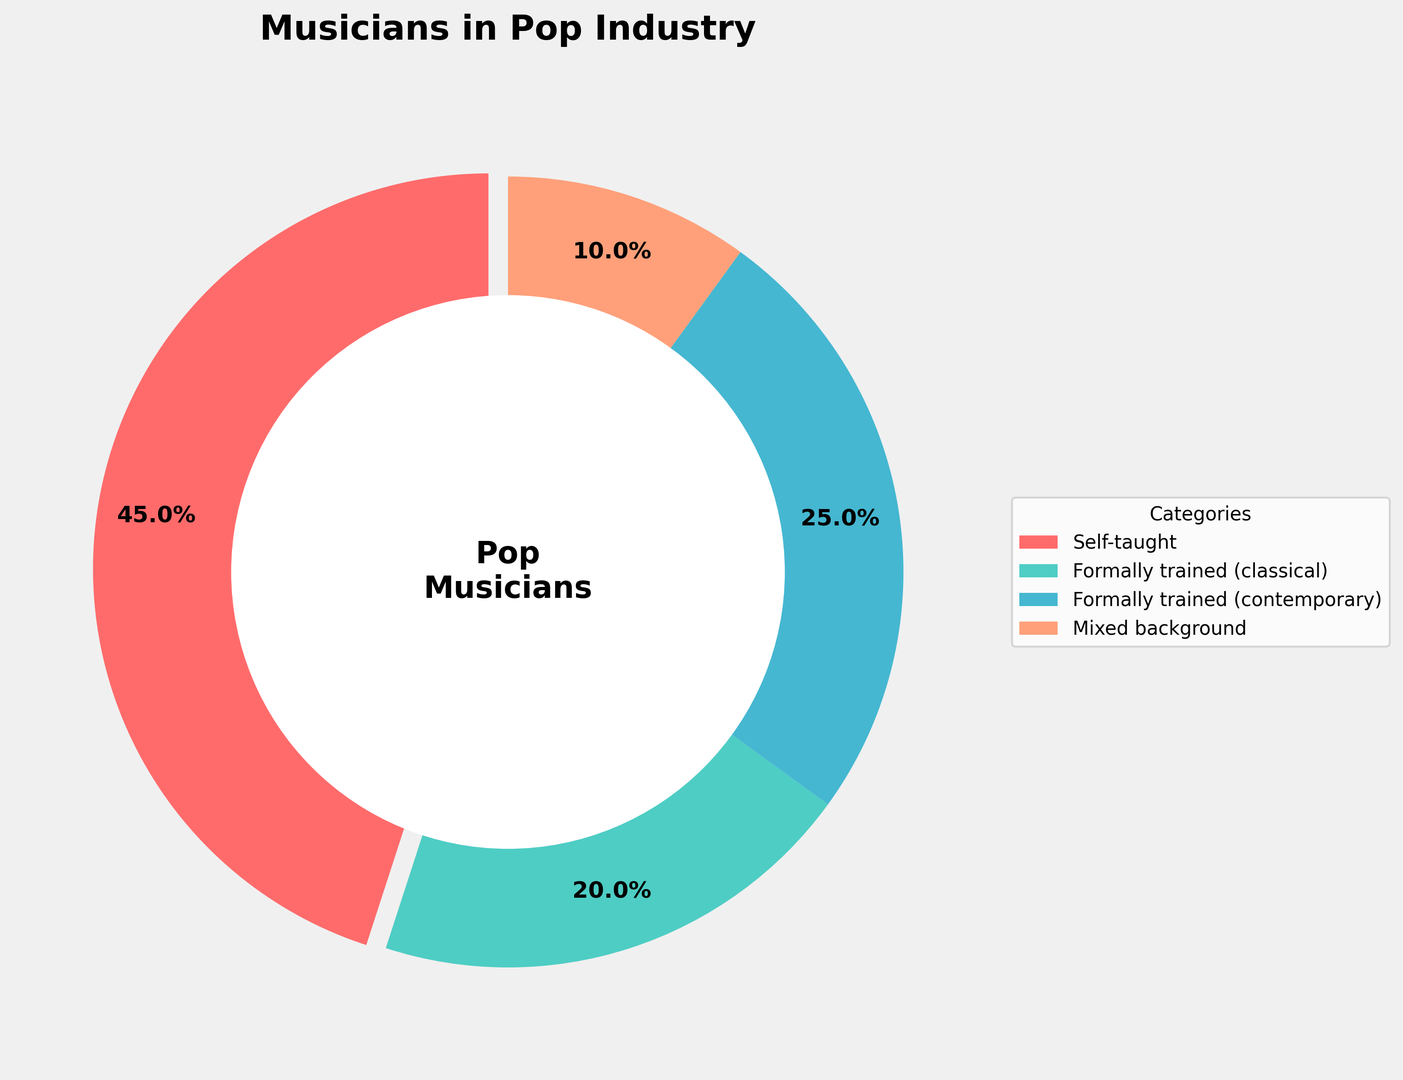What percentage of musicians in the pop industry are self-taught? Look at the segment labeled "Self-taught" in the ring chart and find the percentage value.
Answer: 45% Which category has the smallest percentage of musicians in the pop industry? Compare the percentages of all categories and identify the smallest one.
Answer: Mixed background What is the total percentage of formally trained musicians (including both classical and contemporary)? Add the percentages of "Formally trained (classical)" and "Formally trained (contemporary)". So, 20 + 25 = 45%.
Answer: 45% How does the percentage of self-taught musicians compare to formally trained (classical) musicians? Compare the percentage value of "Self-taught" (45%) with "Formally trained (classical)" (20%). 45% is more than 20%.
Answer: Self-taught > Formally trained (classical) Is the percentage of musicians with a mixed background higher than those with contemporary formal training? Compare the percentage value of "Mixed background" (10%) with "Formally trained (contemporary)" (25%). 10% is less than 25%.
Answer: No Which segment represents the largest group of musicians in the pop industry, and what is its percentage? Identify the segment with the largest percentage by comparing all segments. The "Self-taught" category is the largest with 45%.
Answer: Self-taught, 45% What is the combined percentage of all musicians who have any formal training background (classical, contemporary, or mixed)? Add the percentages of "Formally trained (classical)", "Formally trained (contemporary)", and "Mixed background". So, 20 + 25 + 10 = 55%.
Answer: 55% How much less is the percentage of mixed background musicians compared to self-taught musicians? Subtract the percentage of "Mixed background" musicians (10%) from "Self-taught" musicians (45%). So, 45 - 10 = 35%.
Answer: 35% What percentage of musicians in the pop industry have backgrounds in contemporary music training? Look at the segment labeled "Formally trained (contemporary)" in the ring chart and find the percentage value.
Answer: 25% Are there more musicians with formal classical training or those with a mixed background? Compare the percentage value of "Formally trained (classical)" (20%) with "Mixed background" (10%). 20% is more than 10%.
Answer: Formally trained (classical) 